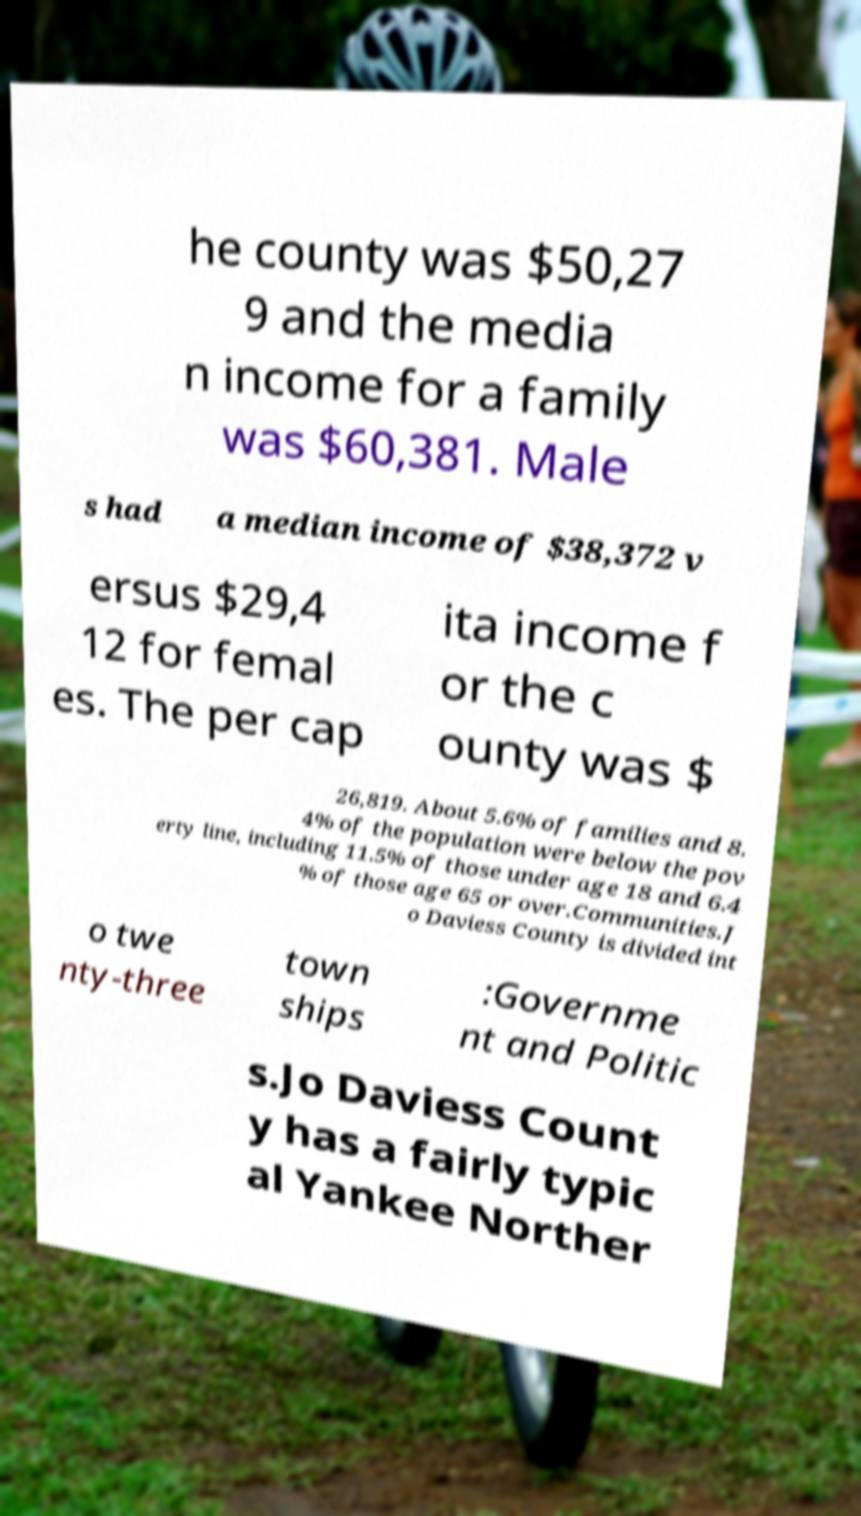Could you assist in decoding the text presented in this image and type it out clearly? he county was $50,27 9 and the media n income for a family was $60,381. Male s had a median income of $38,372 v ersus $29,4 12 for femal es. The per cap ita income f or the c ounty was $ 26,819. About 5.6% of families and 8. 4% of the population were below the pov erty line, including 11.5% of those under age 18 and 6.4 % of those age 65 or over.Communities.J o Daviess County is divided int o twe nty-three town ships :Governme nt and Politic s.Jo Daviess Count y has a fairly typic al Yankee Norther 